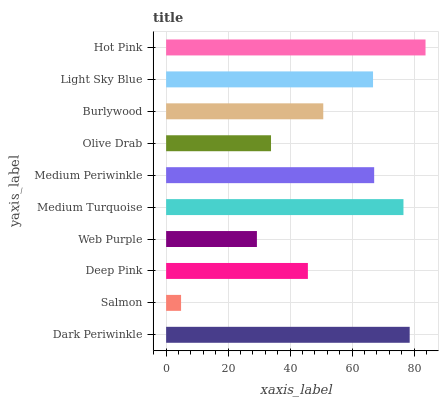Is Salmon the minimum?
Answer yes or no. Yes. Is Hot Pink the maximum?
Answer yes or no. Yes. Is Deep Pink the minimum?
Answer yes or no. No. Is Deep Pink the maximum?
Answer yes or no. No. Is Deep Pink greater than Salmon?
Answer yes or no. Yes. Is Salmon less than Deep Pink?
Answer yes or no. Yes. Is Salmon greater than Deep Pink?
Answer yes or no. No. Is Deep Pink less than Salmon?
Answer yes or no. No. Is Light Sky Blue the high median?
Answer yes or no. Yes. Is Burlywood the low median?
Answer yes or no. Yes. Is Medium Turquoise the high median?
Answer yes or no. No. Is Dark Periwinkle the low median?
Answer yes or no. No. 